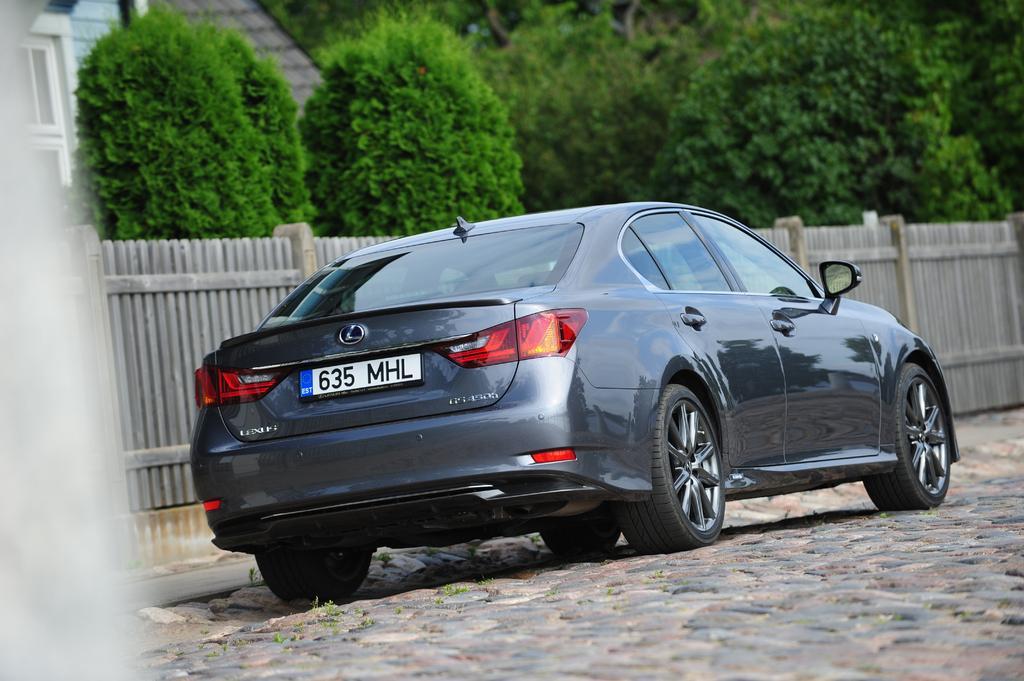Can you describe this image briefly? In this image we can see a car with number plate is parked on the ground. In the background, we can see a fence, a group of trees and a building with windows and roof. 